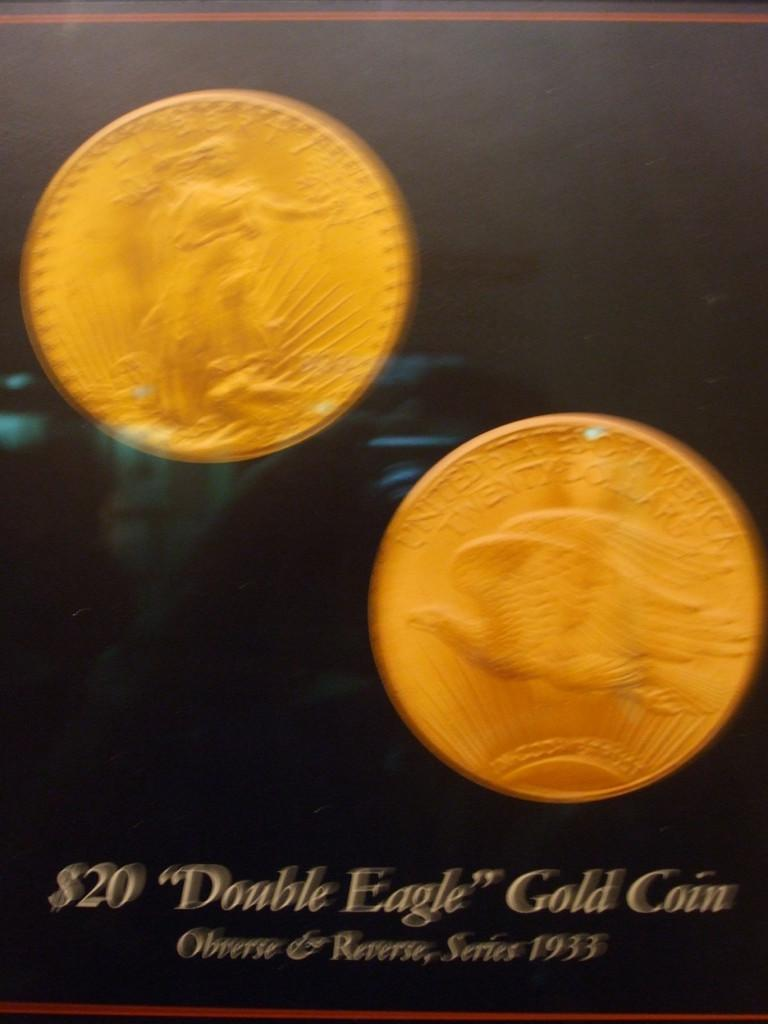<image>
Write a terse but informative summary of the picture. A pair of 1933 "Double Eagle" gold coins worth $20. 